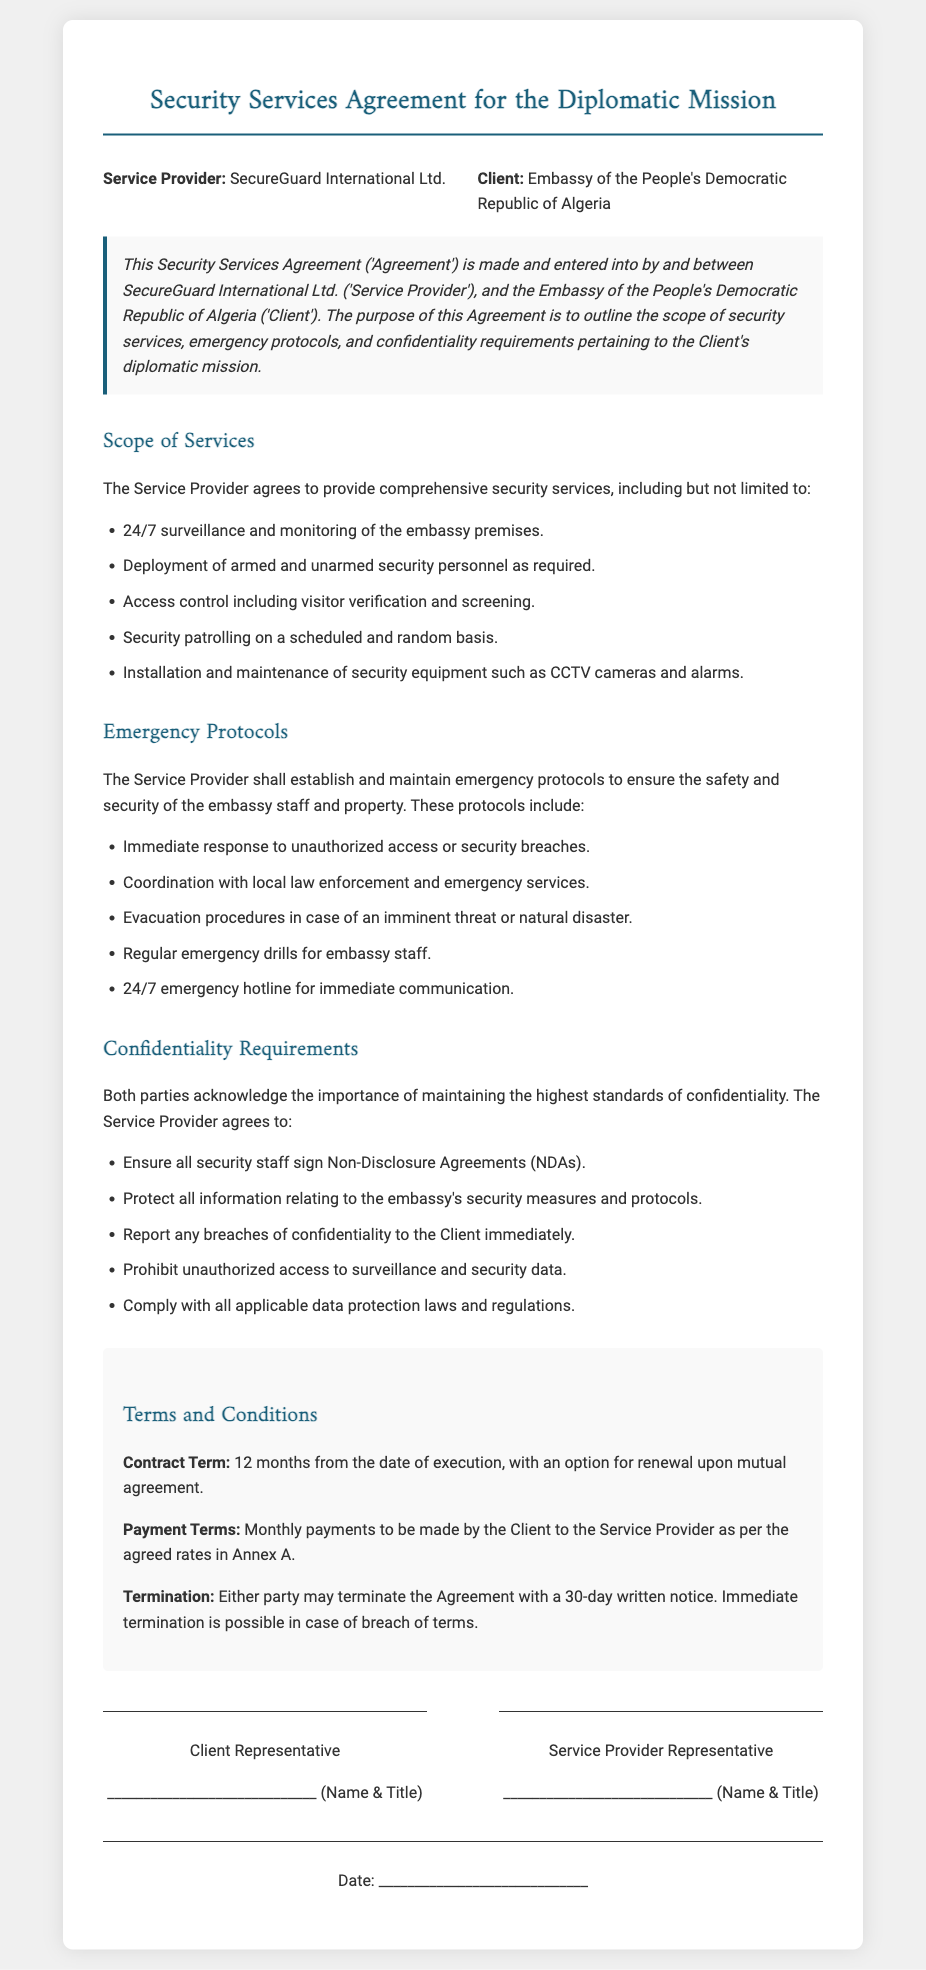What is the name of the Service Provider? The name of the Service Provider is stated in the introduction as SecureGuard International Ltd.
Answer: SecureGuard International Ltd What is the duration of the contract? The contract term is specified in the terms and conditions section as 12 months from the date of execution.
Answer: 12 months What types of security personnel may be deployed? The document mentions armed and unarmed security personnel as part of the scope of services.
Answer: Armed and unarmed What are the emergency procedures mentioned for security breaches? The document lists immediate response to unauthorized access or security breaches as one of the emergency protocols.
Answer: Immediate response What should the Service Provider do in case of a confidentiality breach? The Service Provider must report any breaches of confidentiality to the Client immediately.
Answer: Report immediately What is required for access control? The document states that visitor verification and screening is required for access control.
Answer: Visitor verification and screening How often should emergency drills be conducted? The document specifies that regular emergency drills should be conducted for embassy staff.
Answer: Regularly What is the payment structure mentioned in the contract? The payment terms section indicates that monthly payments are to be made by the Client to the Service Provider.
Answer: Monthly payments What must all security staff sign according to the confidentiality requirements? The document requires that all security staff sign Non-Disclosure Agreements (NDAs).
Answer: Non-Disclosure Agreements (NDAs) 